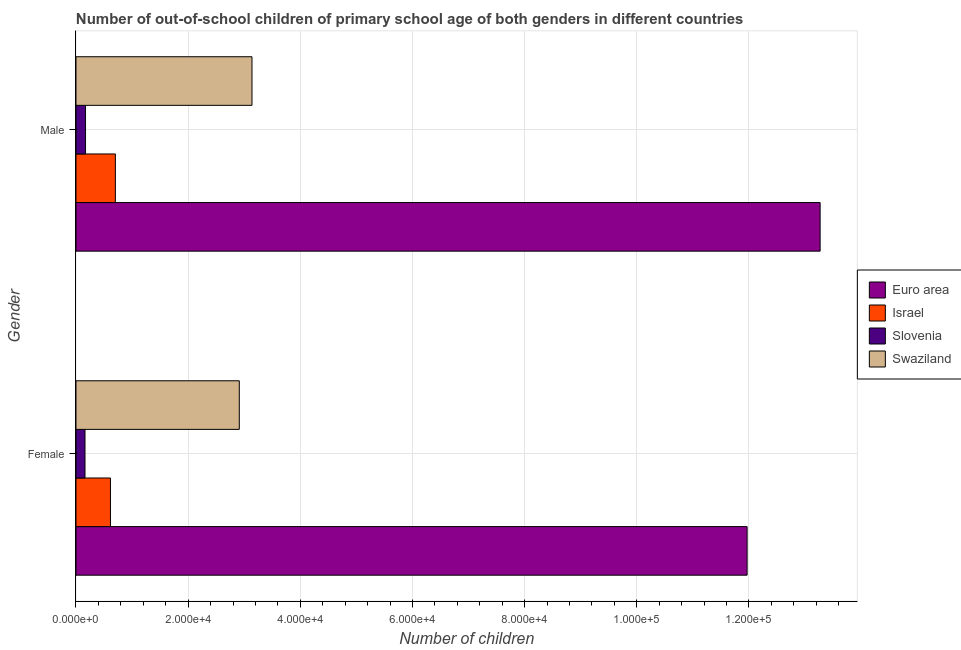How many different coloured bars are there?
Give a very brief answer. 4. How many groups of bars are there?
Provide a succinct answer. 2. Are the number of bars per tick equal to the number of legend labels?
Make the answer very short. Yes. Are the number of bars on each tick of the Y-axis equal?
Your response must be concise. Yes. How many bars are there on the 1st tick from the top?
Provide a succinct answer. 4. How many bars are there on the 2nd tick from the bottom?
Provide a short and direct response. 4. What is the label of the 2nd group of bars from the top?
Your response must be concise. Female. What is the number of male out-of-school students in Swaziland?
Offer a very short reply. 3.14e+04. Across all countries, what is the maximum number of male out-of-school students?
Provide a succinct answer. 1.33e+05. Across all countries, what is the minimum number of female out-of-school students?
Your response must be concise. 1607. In which country was the number of male out-of-school students minimum?
Ensure brevity in your answer.  Slovenia. What is the total number of male out-of-school students in the graph?
Ensure brevity in your answer.  1.73e+05. What is the difference between the number of female out-of-school students in Euro area and that in Slovenia?
Ensure brevity in your answer.  1.18e+05. What is the difference between the number of female out-of-school students in Swaziland and the number of male out-of-school students in Euro area?
Give a very brief answer. -1.04e+05. What is the average number of male out-of-school students per country?
Offer a very short reply. 4.32e+04. What is the difference between the number of female out-of-school students and number of male out-of-school students in Slovenia?
Make the answer very short. -94. In how many countries, is the number of female out-of-school students greater than 44000 ?
Your answer should be compact. 1. What is the ratio of the number of male out-of-school students in Israel to that in Euro area?
Keep it short and to the point. 0.05. In how many countries, is the number of female out-of-school students greater than the average number of female out-of-school students taken over all countries?
Keep it short and to the point. 1. What does the 4th bar from the top in Male represents?
Your answer should be compact. Euro area. What does the 3rd bar from the bottom in Female represents?
Ensure brevity in your answer.  Slovenia. How many bars are there?
Your answer should be very brief. 8. Are all the bars in the graph horizontal?
Ensure brevity in your answer.  Yes. Are the values on the major ticks of X-axis written in scientific E-notation?
Make the answer very short. Yes. Does the graph contain any zero values?
Give a very brief answer. No. What is the title of the graph?
Offer a terse response. Number of out-of-school children of primary school age of both genders in different countries. What is the label or title of the X-axis?
Your answer should be compact. Number of children. What is the Number of children in Euro area in Female?
Offer a terse response. 1.20e+05. What is the Number of children in Israel in Female?
Keep it short and to the point. 6145. What is the Number of children of Slovenia in Female?
Your response must be concise. 1607. What is the Number of children in Swaziland in Female?
Ensure brevity in your answer.  2.91e+04. What is the Number of children in Euro area in Male?
Make the answer very short. 1.33e+05. What is the Number of children in Israel in Male?
Your answer should be very brief. 7024. What is the Number of children in Slovenia in Male?
Provide a succinct answer. 1701. What is the Number of children of Swaziland in Male?
Provide a succinct answer. 3.14e+04. Across all Gender, what is the maximum Number of children of Euro area?
Offer a terse response. 1.33e+05. Across all Gender, what is the maximum Number of children of Israel?
Your response must be concise. 7024. Across all Gender, what is the maximum Number of children in Slovenia?
Provide a short and direct response. 1701. Across all Gender, what is the maximum Number of children in Swaziland?
Give a very brief answer. 3.14e+04. Across all Gender, what is the minimum Number of children of Euro area?
Make the answer very short. 1.20e+05. Across all Gender, what is the minimum Number of children of Israel?
Ensure brevity in your answer.  6145. Across all Gender, what is the minimum Number of children in Slovenia?
Keep it short and to the point. 1607. Across all Gender, what is the minimum Number of children in Swaziland?
Your answer should be very brief. 2.91e+04. What is the total Number of children in Euro area in the graph?
Offer a terse response. 2.52e+05. What is the total Number of children in Israel in the graph?
Ensure brevity in your answer.  1.32e+04. What is the total Number of children of Slovenia in the graph?
Provide a short and direct response. 3308. What is the total Number of children in Swaziland in the graph?
Make the answer very short. 6.05e+04. What is the difference between the Number of children of Euro area in Female and that in Male?
Give a very brief answer. -1.30e+04. What is the difference between the Number of children in Israel in Female and that in Male?
Provide a short and direct response. -879. What is the difference between the Number of children in Slovenia in Female and that in Male?
Make the answer very short. -94. What is the difference between the Number of children in Swaziland in Female and that in Male?
Offer a terse response. -2261. What is the difference between the Number of children of Euro area in Female and the Number of children of Israel in Male?
Make the answer very short. 1.13e+05. What is the difference between the Number of children in Euro area in Female and the Number of children in Slovenia in Male?
Keep it short and to the point. 1.18e+05. What is the difference between the Number of children of Euro area in Female and the Number of children of Swaziland in Male?
Offer a very short reply. 8.83e+04. What is the difference between the Number of children of Israel in Female and the Number of children of Slovenia in Male?
Offer a very short reply. 4444. What is the difference between the Number of children in Israel in Female and the Number of children in Swaziland in Male?
Your answer should be compact. -2.52e+04. What is the difference between the Number of children in Slovenia in Female and the Number of children in Swaziland in Male?
Keep it short and to the point. -2.98e+04. What is the average Number of children of Euro area per Gender?
Your answer should be very brief. 1.26e+05. What is the average Number of children of Israel per Gender?
Give a very brief answer. 6584.5. What is the average Number of children in Slovenia per Gender?
Keep it short and to the point. 1654. What is the average Number of children of Swaziland per Gender?
Ensure brevity in your answer.  3.03e+04. What is the difference between the Number of children of Euro area and Number of children of Israel in Female?
Keep it short and to the point. 1.14e+05. What is the difference between the Number of children of Euro area and Number of children of Slovenia in Female?
Offer a terse response. 1.18e+05. What is the difference between the Number of children in Euro area and Number of children in Swaziland in Female?
Give a very brief answer. 9.05e+04. What is the difference between the Number of children in Israel and Number of children in Slovenia in Female?
Offer a terse response. 4538. What is the difference between the Number of children of Israel and Number of children of Swaziland in Female?
Ensure brevity in your answer.  -2.30e+04. What is the difference between the Number of children in Slovenia and Number of children in Swaziland in Female?
Offer a terse response. -2.75e+04. What is the difference between the Number of children of Euro area and Number of children of Israel in Male?
Offer a terse response. 1.26e+05. What is the difference between the Number of children in Euro area and Number of children in Slovenia in Male?
Offer a terse response. 1.31e+05. What is the difference between the Number of children in Euro area and Number of children in Swaziland in Male?
Offer a terse response. 1.01e+05. What is the difference between the Number of children of Israel and Number of children of Slovenia in Male?
Give a very brief answer. 5323. What is the difference between the Number of children of Israel and Number of children of Swaziland in Male?
Provide a short and direct response. -2.44e+04. What is the difference between the Number of children of Slovenia and Number of children of Swaziland in Male?
Keep it short and to the point. -2.97e+04. What is the ratio of the Number of children in Euro area in Female to that in Male?
Your answer should be compact. 0.9. What is the ratio of the Number of children in Israel in Female to that in Male?
Your response must be concise. 0.87. What is the ratio of the Number of children of Slovenia in Female to that in Male?
Give a very brief answer. 0.94. What is the ratio of the Number of children of Swaziland in Female to that in Male?
Offer a very short reply. 0.93. What is the difference between the highest and the second highest Number of children of Euro area?
Provide a short and direct response. 1.30e+04. What is the difference between the highest and the second highest Number of children of Israel?
Offer a terse response. 879. What is the difference between the highest and the second highest Number of children of Slovenia?
Your answer should be compact. 94. What is the difference between the highest and the second highest Number of children of Swaziland?
Provide a short and direct response. 2261. What is the difference between the highest and the lowest Number of children in Euro area?
Make the answer very short. 1.30e+04. What is the difference between the highest and the lowest Number of children of Israel?
Your answer should be very brief. 879. What is the difference between the highest and the lowest Number of children in Slovenia?
Keep it short and to the point. 94. What is the difference between the highest and the lowest Number of children of Swaziland?
Ensure brevity in your answer.  2261. 